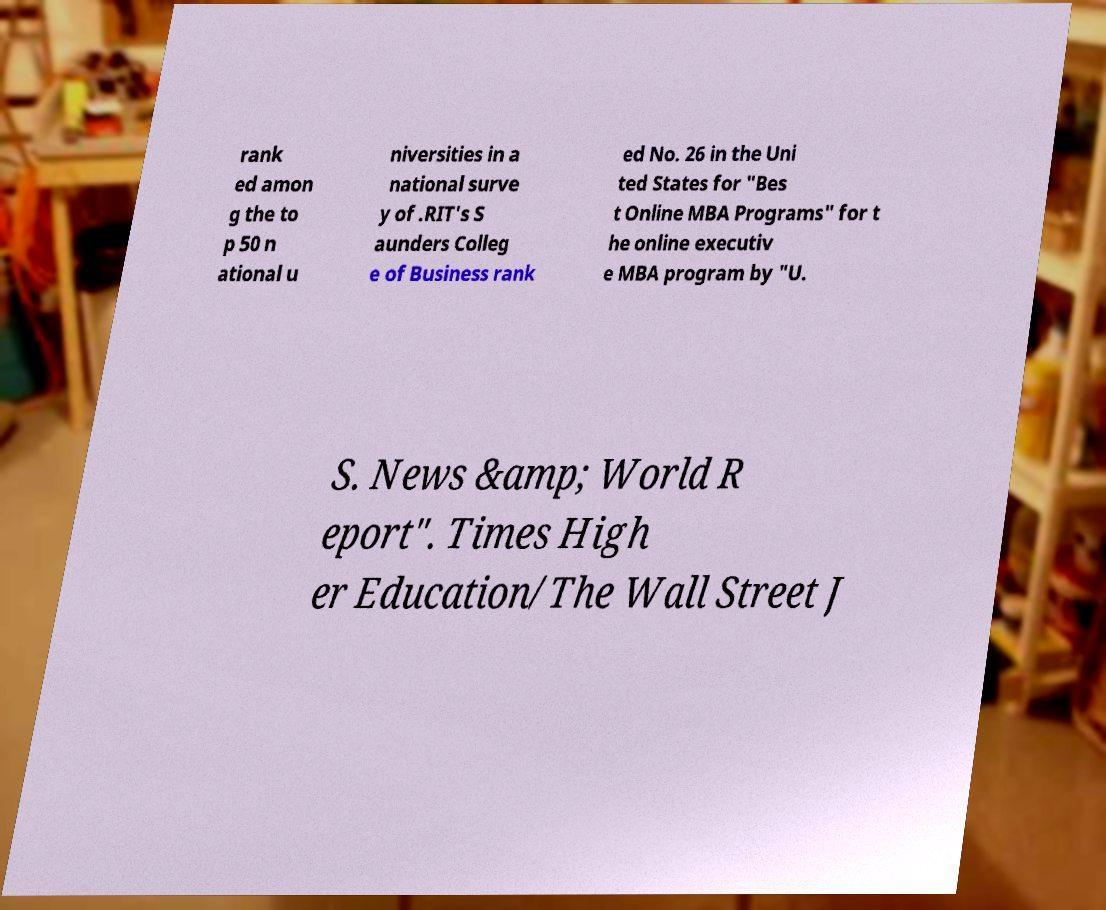I need the written content from this picture converted into text. Can you do that? rank ed amon g the to p 50 n ational u niversities in a national surve y of .RIT's S aunders Colleg e of Business rank ed No. 26 in the Uni ted States for "Bes t Online MBA Programs" for t he online executiv e MBA program by "U. S. News &amp; World R eport". Times High er Education/The Wall Street J 